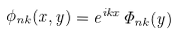Convert formula to latex. <formula><loc_0><loc_0><loc_500><loc_500>\phi _ { n k } ( x , y ) = e ^ { i k x } \Phi _ { n k } ( y )</formula> 